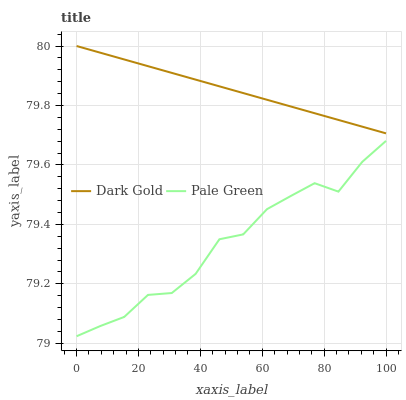Does Pale Green have the minimum area under the curve?
Answer yes or no. Yes. Does Dark Gold have the maximum area under the curve?
Answer yes or no. Yes. Does Dark Gold have the minimum area under the curve?
Answer yes or no. No. Is Dark Gold the smoothest?
Answer yes or no. Yes. Is Pale Green the roughest?
Answer yes or no. Yes. Is Dark Gold the roughest?
Answer yes or no. No. Does Pale Green have the lowest value?
Answer yes or no. Yes. Does Dark Gold have the lowest value?
Answer yes or no. No. Does Dark Gold have the highest value?
Answer yes or no. Yes. Is Pale Green less than Dark Gold?
Answer yes or no. Yes. Is Dark Gold greater than Pale Green?
Answer yes or no. Yes. Does Pale Green intersect Dark Gold?
Answer yes or no. No. 